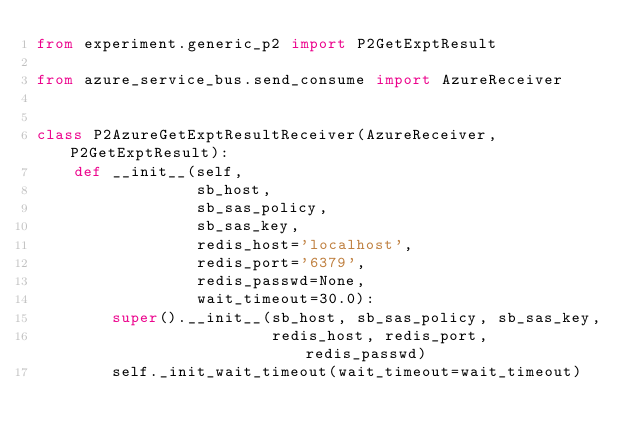Convert code to text. <code><loc_0><loc_0><loc_500><loc_500><_Python_>from experiment.generic_p2 import P2GetExptResult

from azure_service_bus.send_consume import AzureReceiver


class P2AzureGetExptResultReceiver(AzureReceiver, P2GetExptResult):
    def __init__(self,
                 sb_host,
                 sb_sas_policy,
                 sb_sas_key,
                 redis_host='localhost',
                 redis_port='6379',
                 redis_passwd=None,
                 wait_timeout=30.0):
        super().__init__(sb_host, sb_sas_policy, sb_sas_key,
                         redis_host, redis_port, redis_passwd)
        self._init_wait_timeout(wait_timeout=wait_timeout)
</code> 